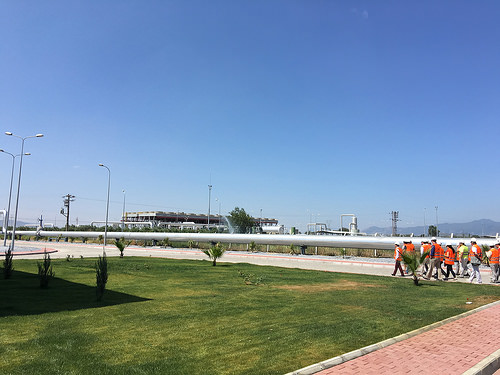<image>
Is the people on the road? Yes. Looking at the image, I can see the people is positioned on top of the road, with the road providing support. Where is the pipe in relation to the man? Is it to the left of the man? No. The pipe is not to the left of the man. From this viewpoint, they have a different horizontal relationship. Where is the woman in relation to the man? Is it to the right of the man? Yes. From this viewpoint, the woman is positioned to the right side relative to the man. 